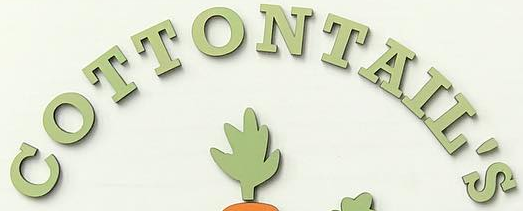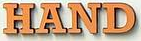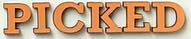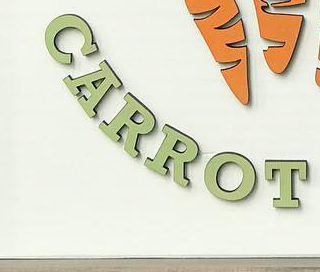What text is displayed in these images sequentially, separated by a semicolon? COTTONTAIL'S; HAND; PICKED; CARROT 